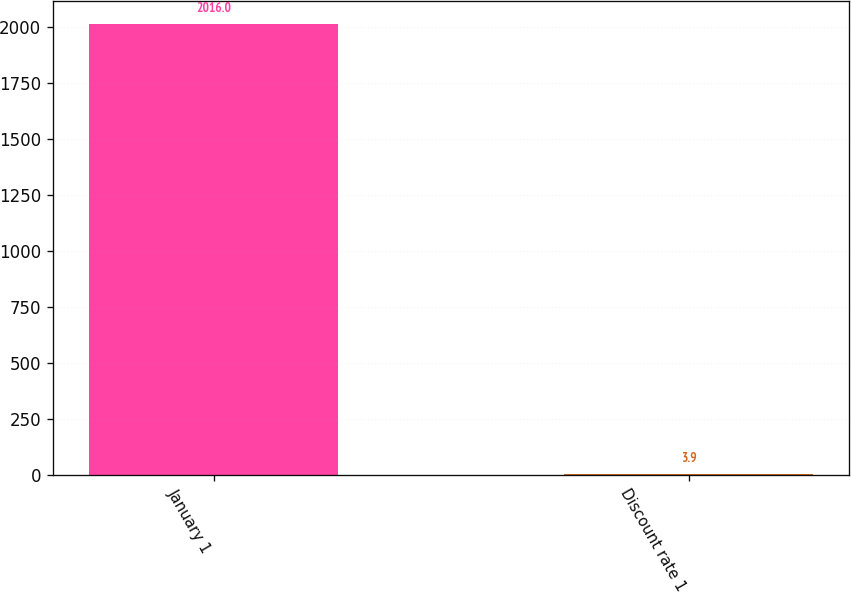<chart> <loc_0><loc_0><loc_500><loc_500><bar_chart><fcel>January 1<fcel>Discount rate 1<nl><fcel>2016<fcel>3.9<nl></chart> 